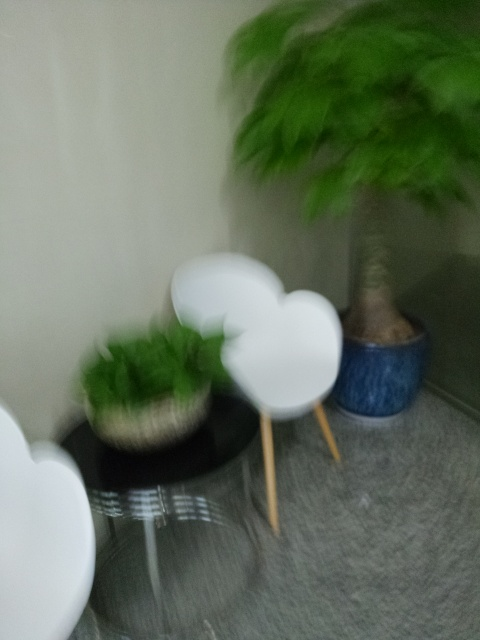Are there any quality issues with this image? Yes, the image is blurry, which indicates motion blur or a focus issue during the capture process. This affects the viewer's ability to discern fine details of the objects, such as the leaves of the plant and the textures on the furniture. 